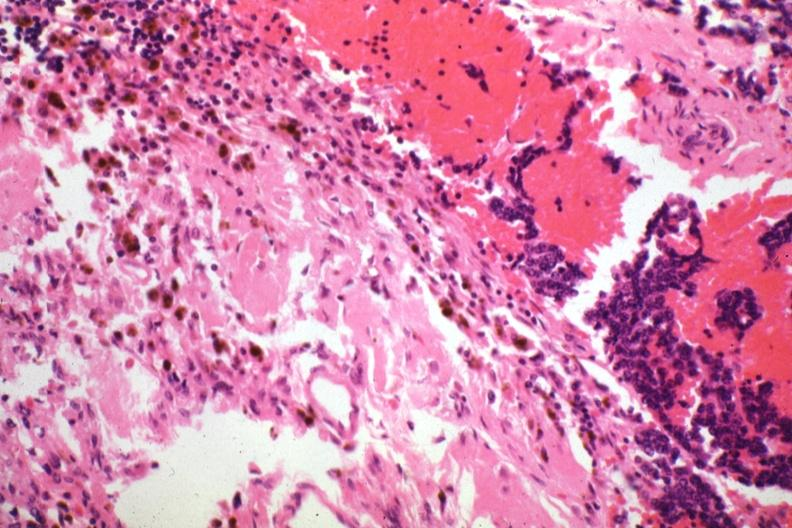where is this part in the figure?
Answer the question using a single word or phrase. Endocrine system 